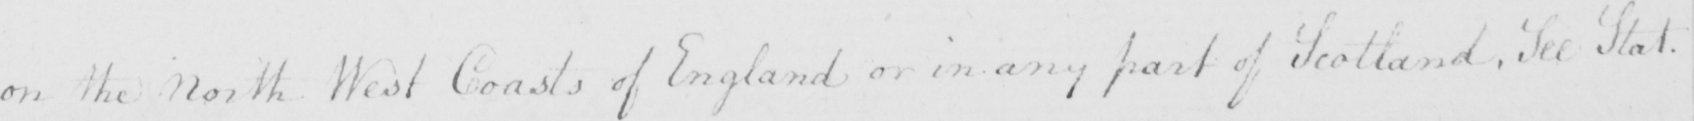Transcribe the text shown in this historical manuscript line. on the North West Coasts of England or in any part of Scotland . See Stat . 